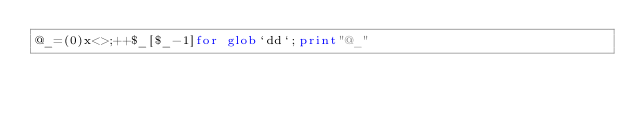Convert code to text. <code><loc_0><loc_0><loc_500><loc_500><_Perl_>@_=(0)x<>;++$_[$_-1]for glob`dd`;print"@_"</code> 